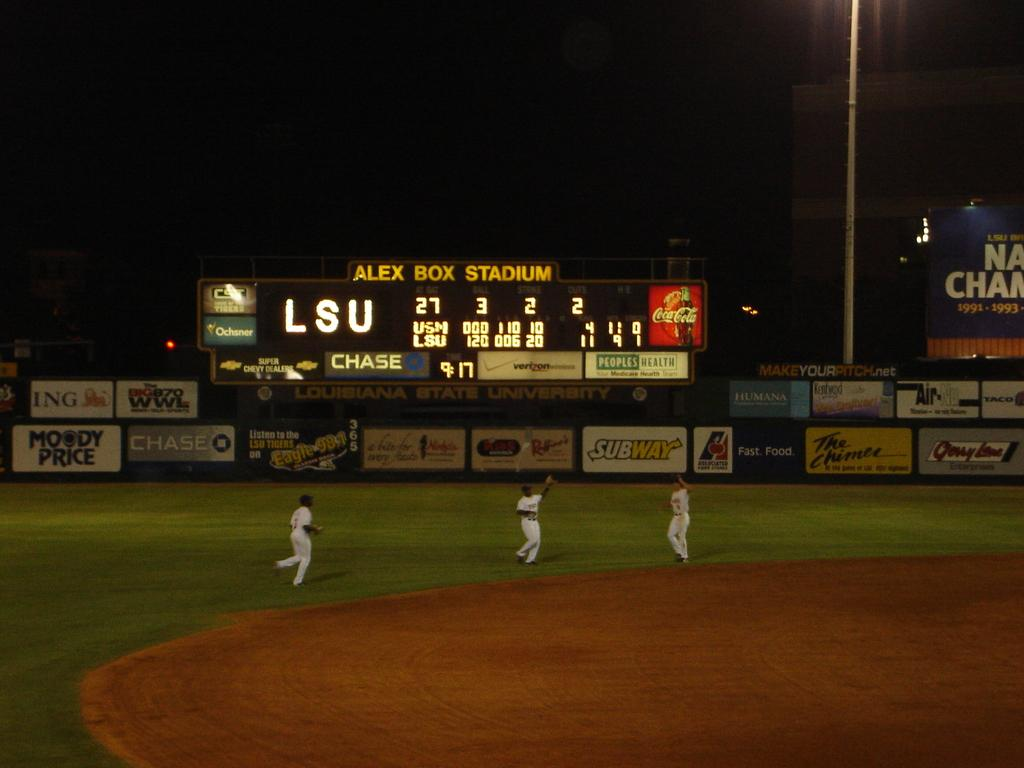Provide a one-sentence caption for the provided image. A baseball stadium is labeled ALEX BOX STADIUM on the scoreboard. 